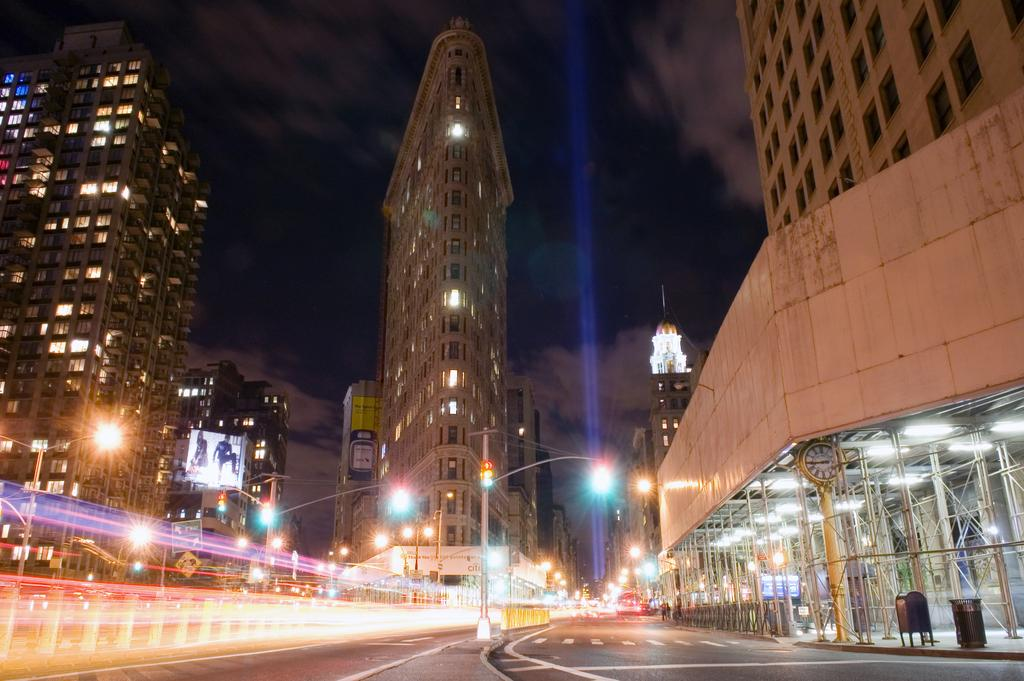What is the main feature of the image? There is a road in the image. What can be seen around the road? There are tall buildings around the road. How are the buildings illuminated? The buildings are lightened up with beautiful lights. What is the appearance of the road? The road is colorful. What type of drink is being served at the table in the image? There is no table or drink present in the image; it features a road and tall buildings. What type of badge is being worn by the person standing near the buildings? There is no person or badge present in the image; it only features a road and tall buildings. 